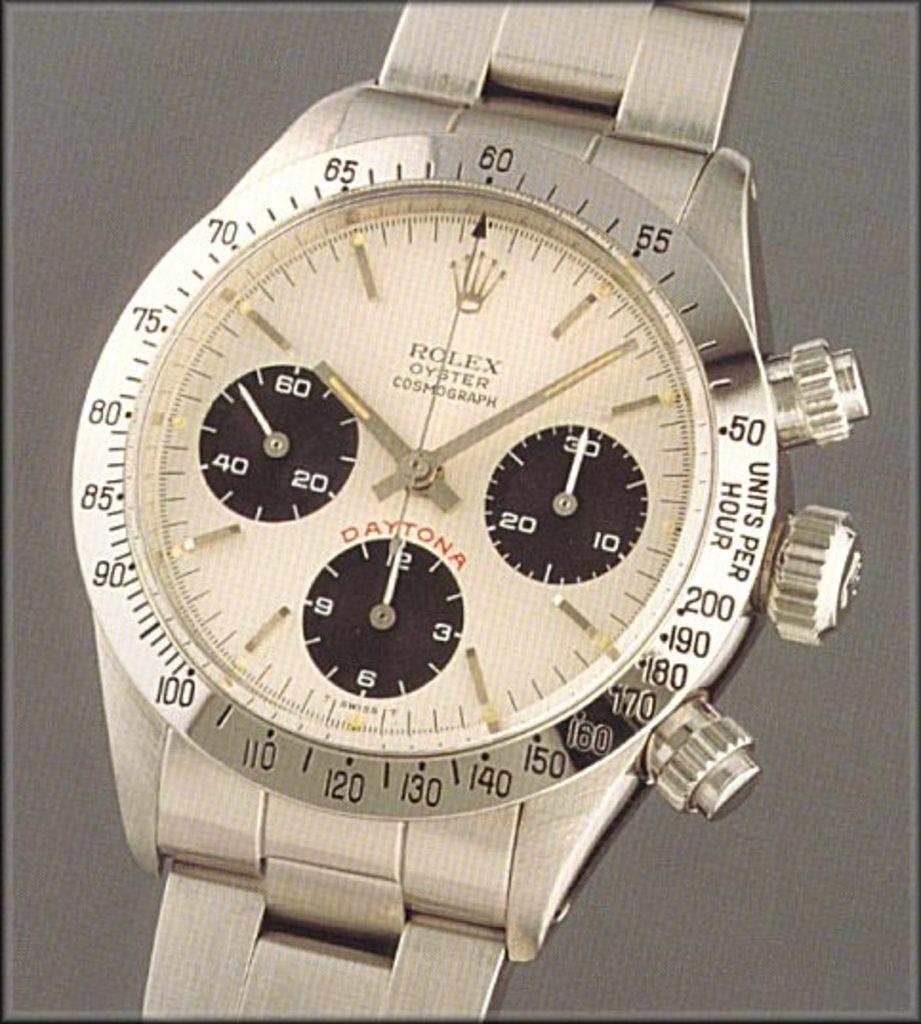Provide a one-sentence caption for the provided image. A closeup on a platinum colored Rolex Oyster watch. 